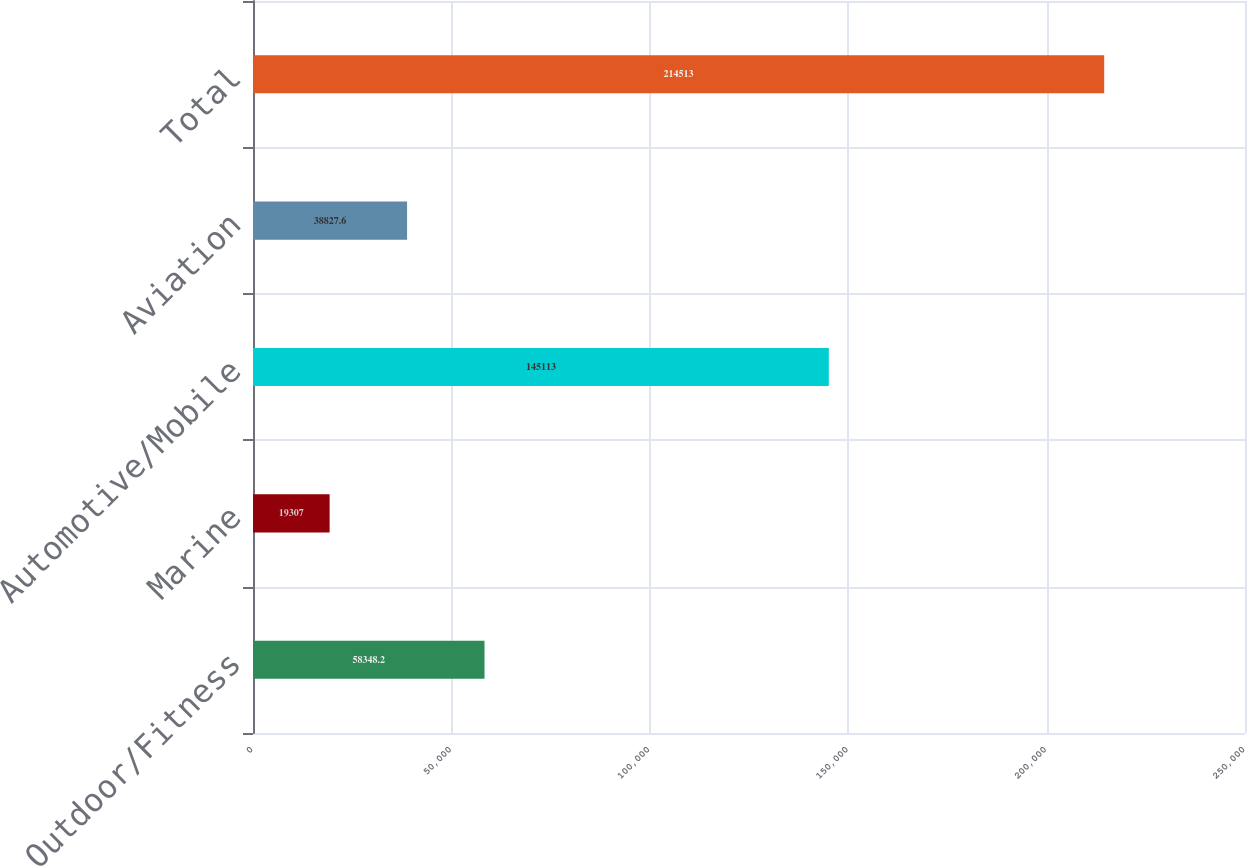<chart> <loc_0><loc_0><loc_500><loc_500><bar_chart><fcel>Outdoor/Fitness<fcel>Marine<fcel>Automotive/Mobile<fcel>Aviation<fcel>Total<nl><fcel>58348.2<fcel>19307<fcel>145113<fcel>38827.6<fcel>214513<nl></chart> 